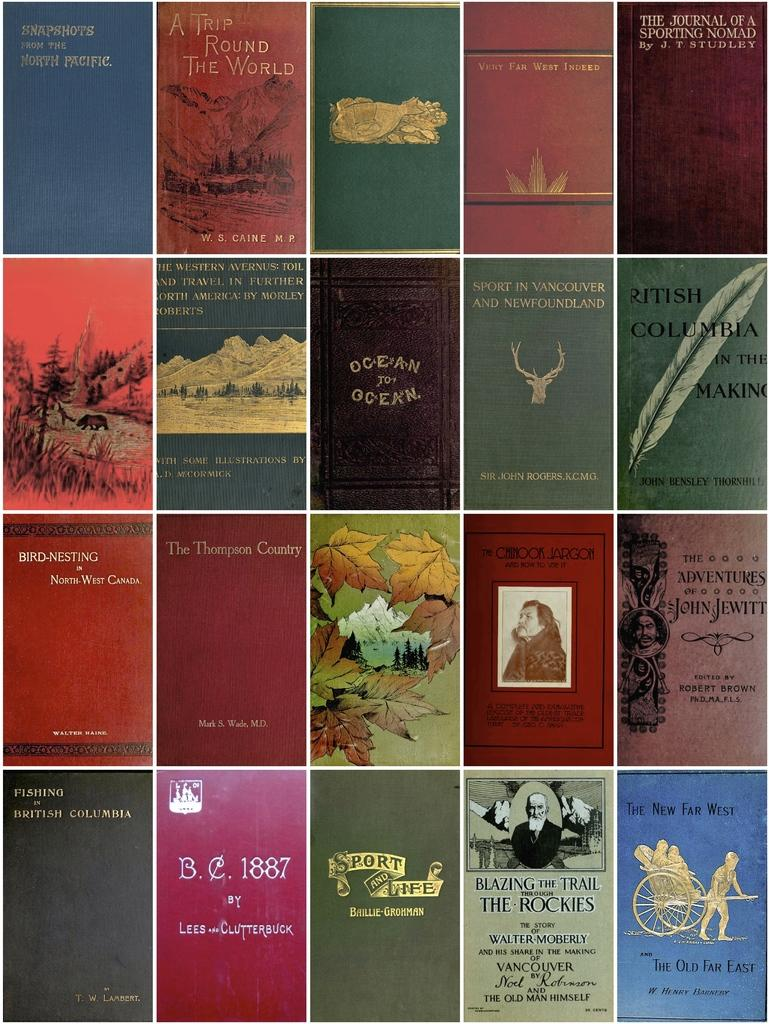Provide a one-sentence caption for the provided image. Ocean To Ocean is laid out above a book with a forest theme. 